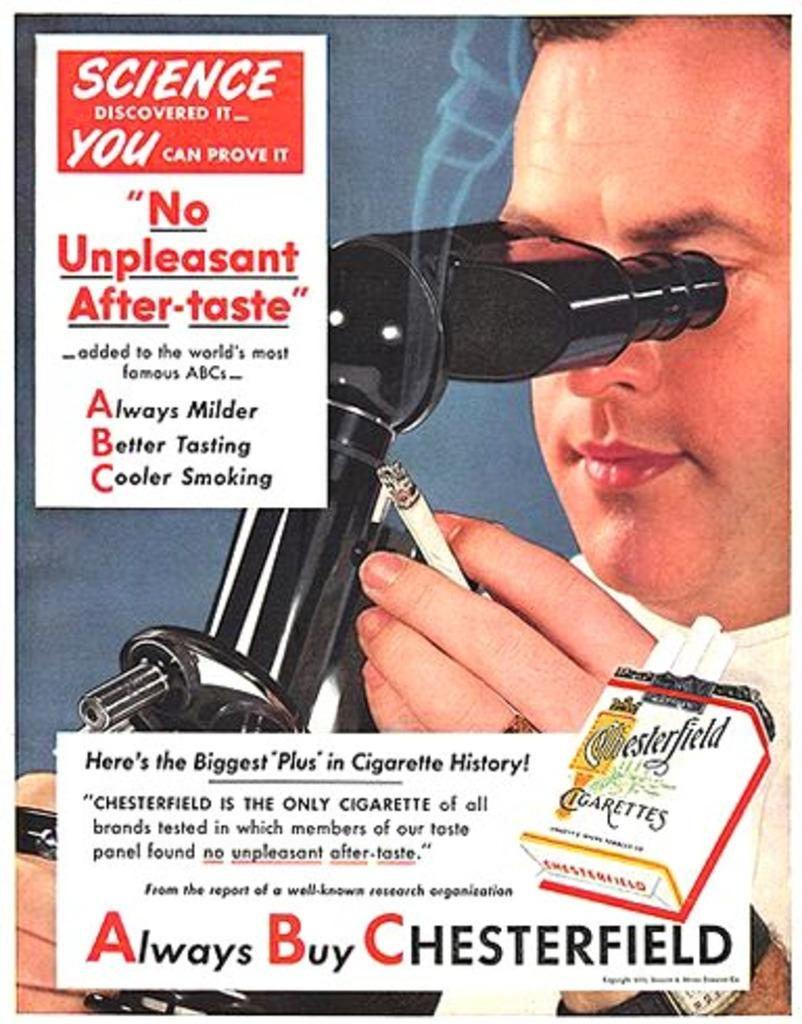What is featured on the poster in the image? There is a poster in the image that contains a man. What is the man holding in his hand? The man is holding a cigarette and a microscope in his hand. Is there any text on the poster? Yes, there is text written on the poster. What type of jam is being served in the vessel on the poster? There is no vessel or jam present on the poster; it features a man holding a cigarette and a microscope. 